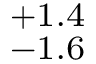<formula> <loc_0><loc_0><loc_500><loc_500>^ { + 1 . 4 } _ { - 1 . 6 }</formula> 